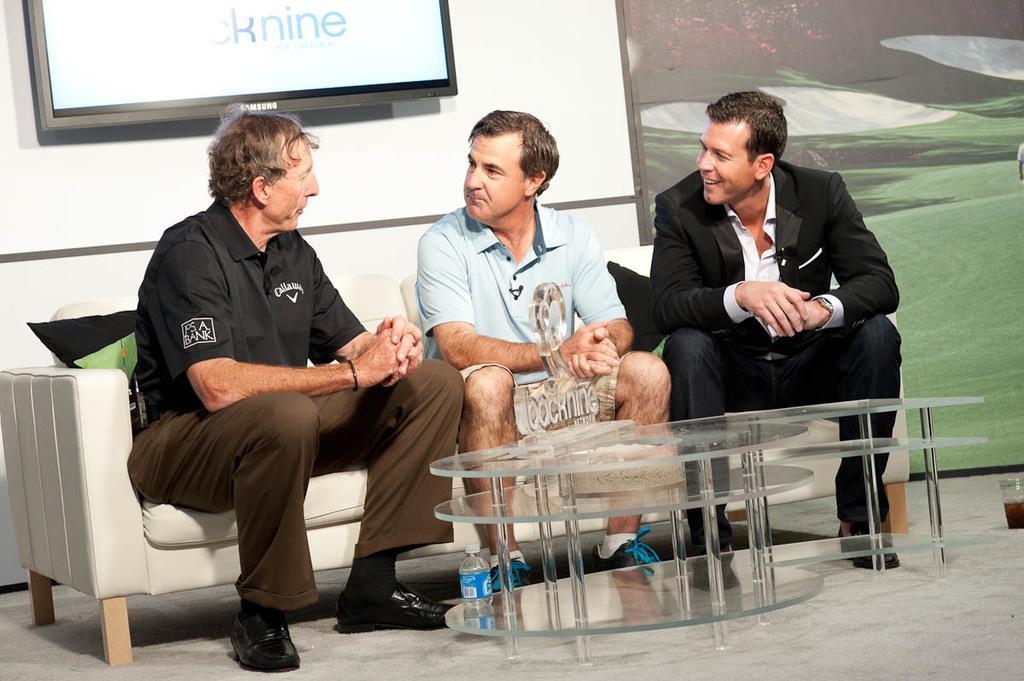How would you summarize this image in a sentence or two? In this image there are three persons who are sitting and talking with each other. In front of them there is one table, on the background there is a wall and one television is there on the table on the right side there is one glass and some posters are there. 